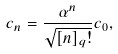<formula> <loc_0><loc_0><loc_500><loc_500>c _ { n } = \frac { \alpha ^ { n } } { \sqrt { [ n ] _ { q } ! } } c _ { 0 } ,</formula> 